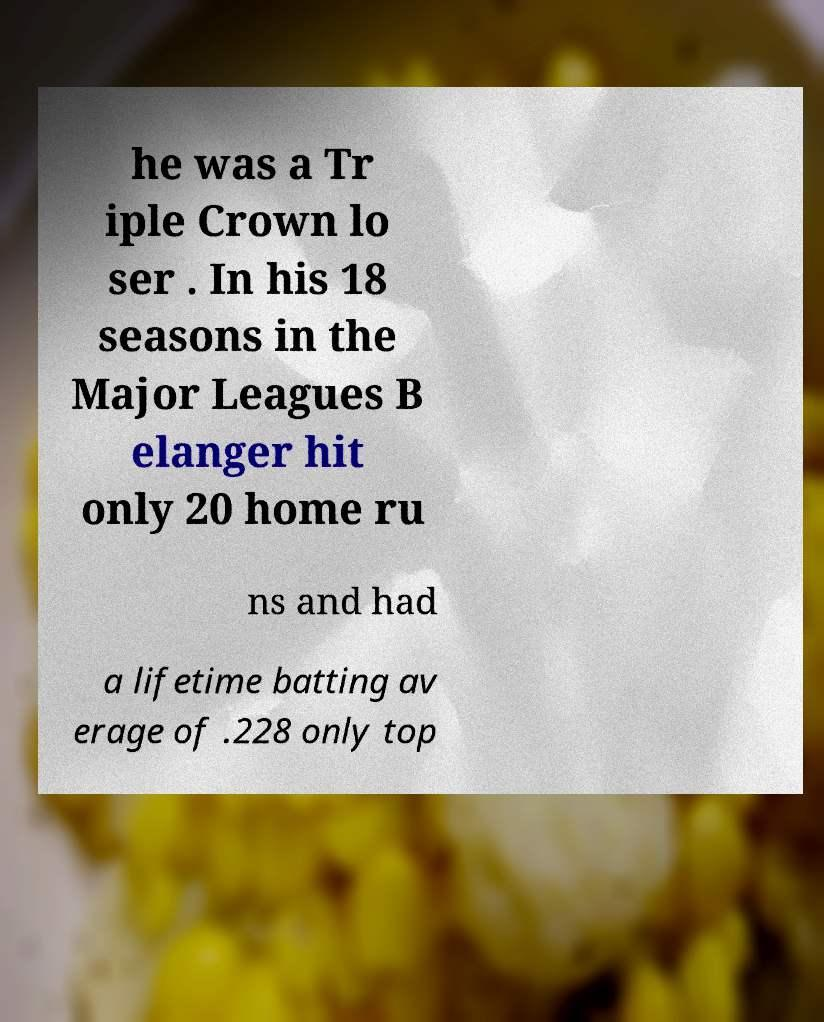Can you read and provide the text displayed in the image?This photo seems to have some interesting text. Can you extract and type it out for me? he was a Tr iple Crown lo ser . In his 18 seasons in the Major Leagues B elanger hit only 20 home ru ns and had a lifetime batting av erage of .228 only top 